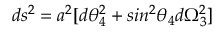<formula> <loc_0><loc_0><loc_500><loc_500>d s ^ { 2 } = a ^ { 2 } [ d \theta _ { 4 } ^ { 2 } + \sin ^ { 2 } \theta _ { 4 } d \Omega _ { 3 } ^ { 2 } ]</formula> 